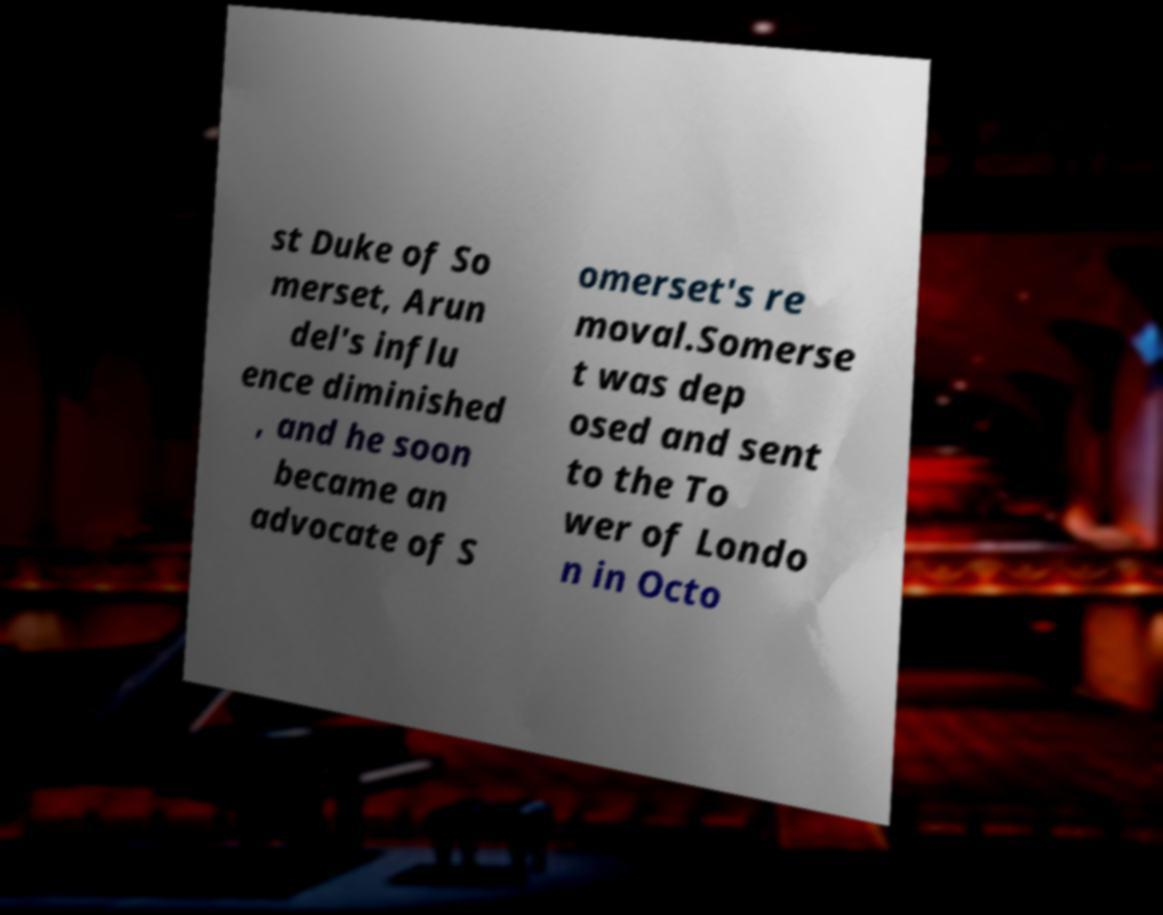Could you assist in decoding the text presented in this image and type it out clearly? st Duke of So merset, Arun del's influ ence diminished , and he soon became an advocate of S omerset's re moval.Somerse t was dep osed and sent to the To wer of Londo n in Octo 